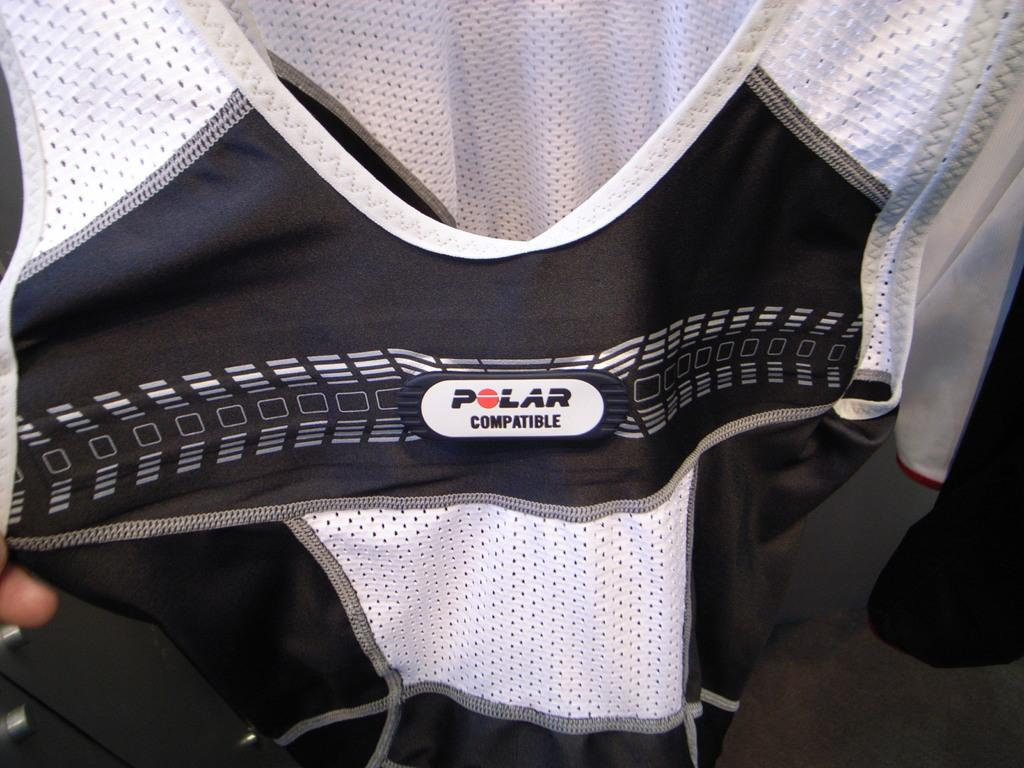What type of clothing is featured in the image? There is a black and white jacket in the image. What can be seen beneath the jacket? The floor is visible in the image. Where is the kitten located in the image? There is no kitten present in the image. What type of bag is visible in the image? There is no bag present in the image. 